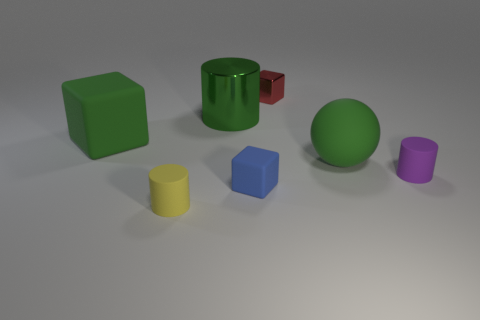Add 1 tiny cubes. How many objects exist? 8 Subtract all tiny rubber cylinders. How many cylinders are left? 1 Subtract all green cylinders. How many cylinders are left? 2 Subtract 3 cubes. How many cubes are left? 0 Subtract all blocks. How many objects are left? 4 Subtract all blue matte objects. Subtract all small purple cylinders. How many objects are left? 5 Add 1 tiny yellow matte cylinders. How many tiny yellow matte cylinders are left? 2 Add 2 tiny red metal cylinders. How many tiny red metal cylinders exist? 2 Subtract 1 green spheres. How many objects are left? 6 Subtract all red blocks. Subtract all red cylinders. How many blocks are left? 2 